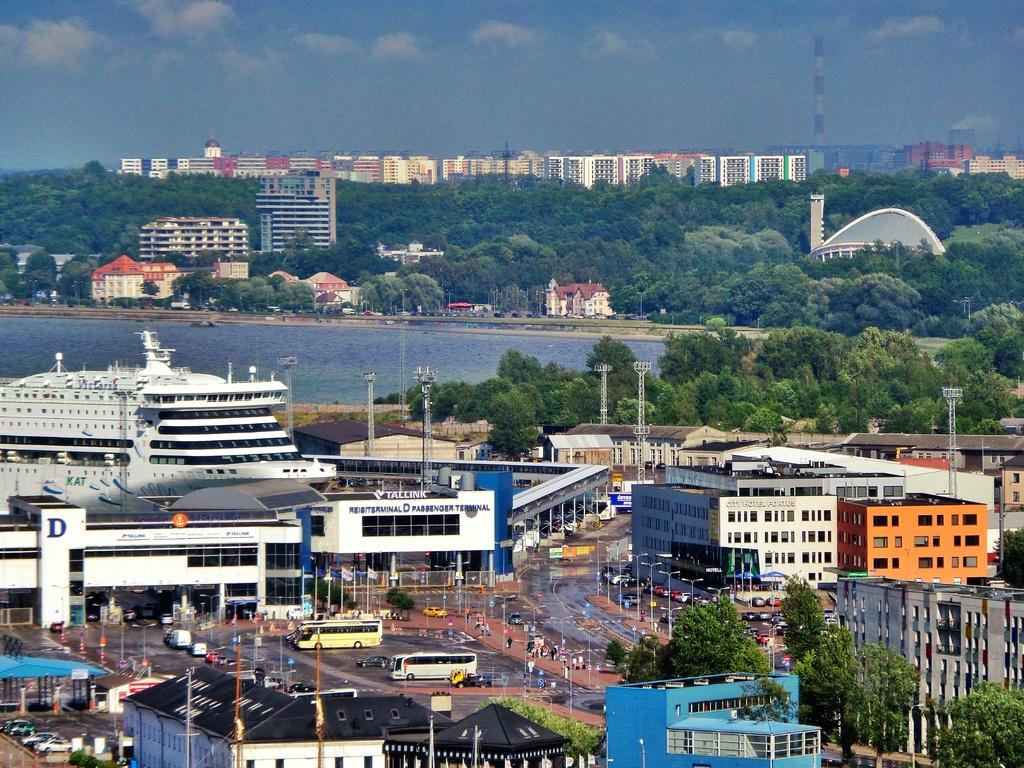What type of structures can be seen in the image? There are buildings in the image. What natural elements are present in the image? There are trees and water visible in the image. What else can be seen in the sky in the image? There is sky visible in the image. What mode of transportation is present in the image? There is a ship in the image. Where is the faucet located in the image? There is no faucet present in the image. What time is displayed on the watch in the image? There is no watch present in the image. 